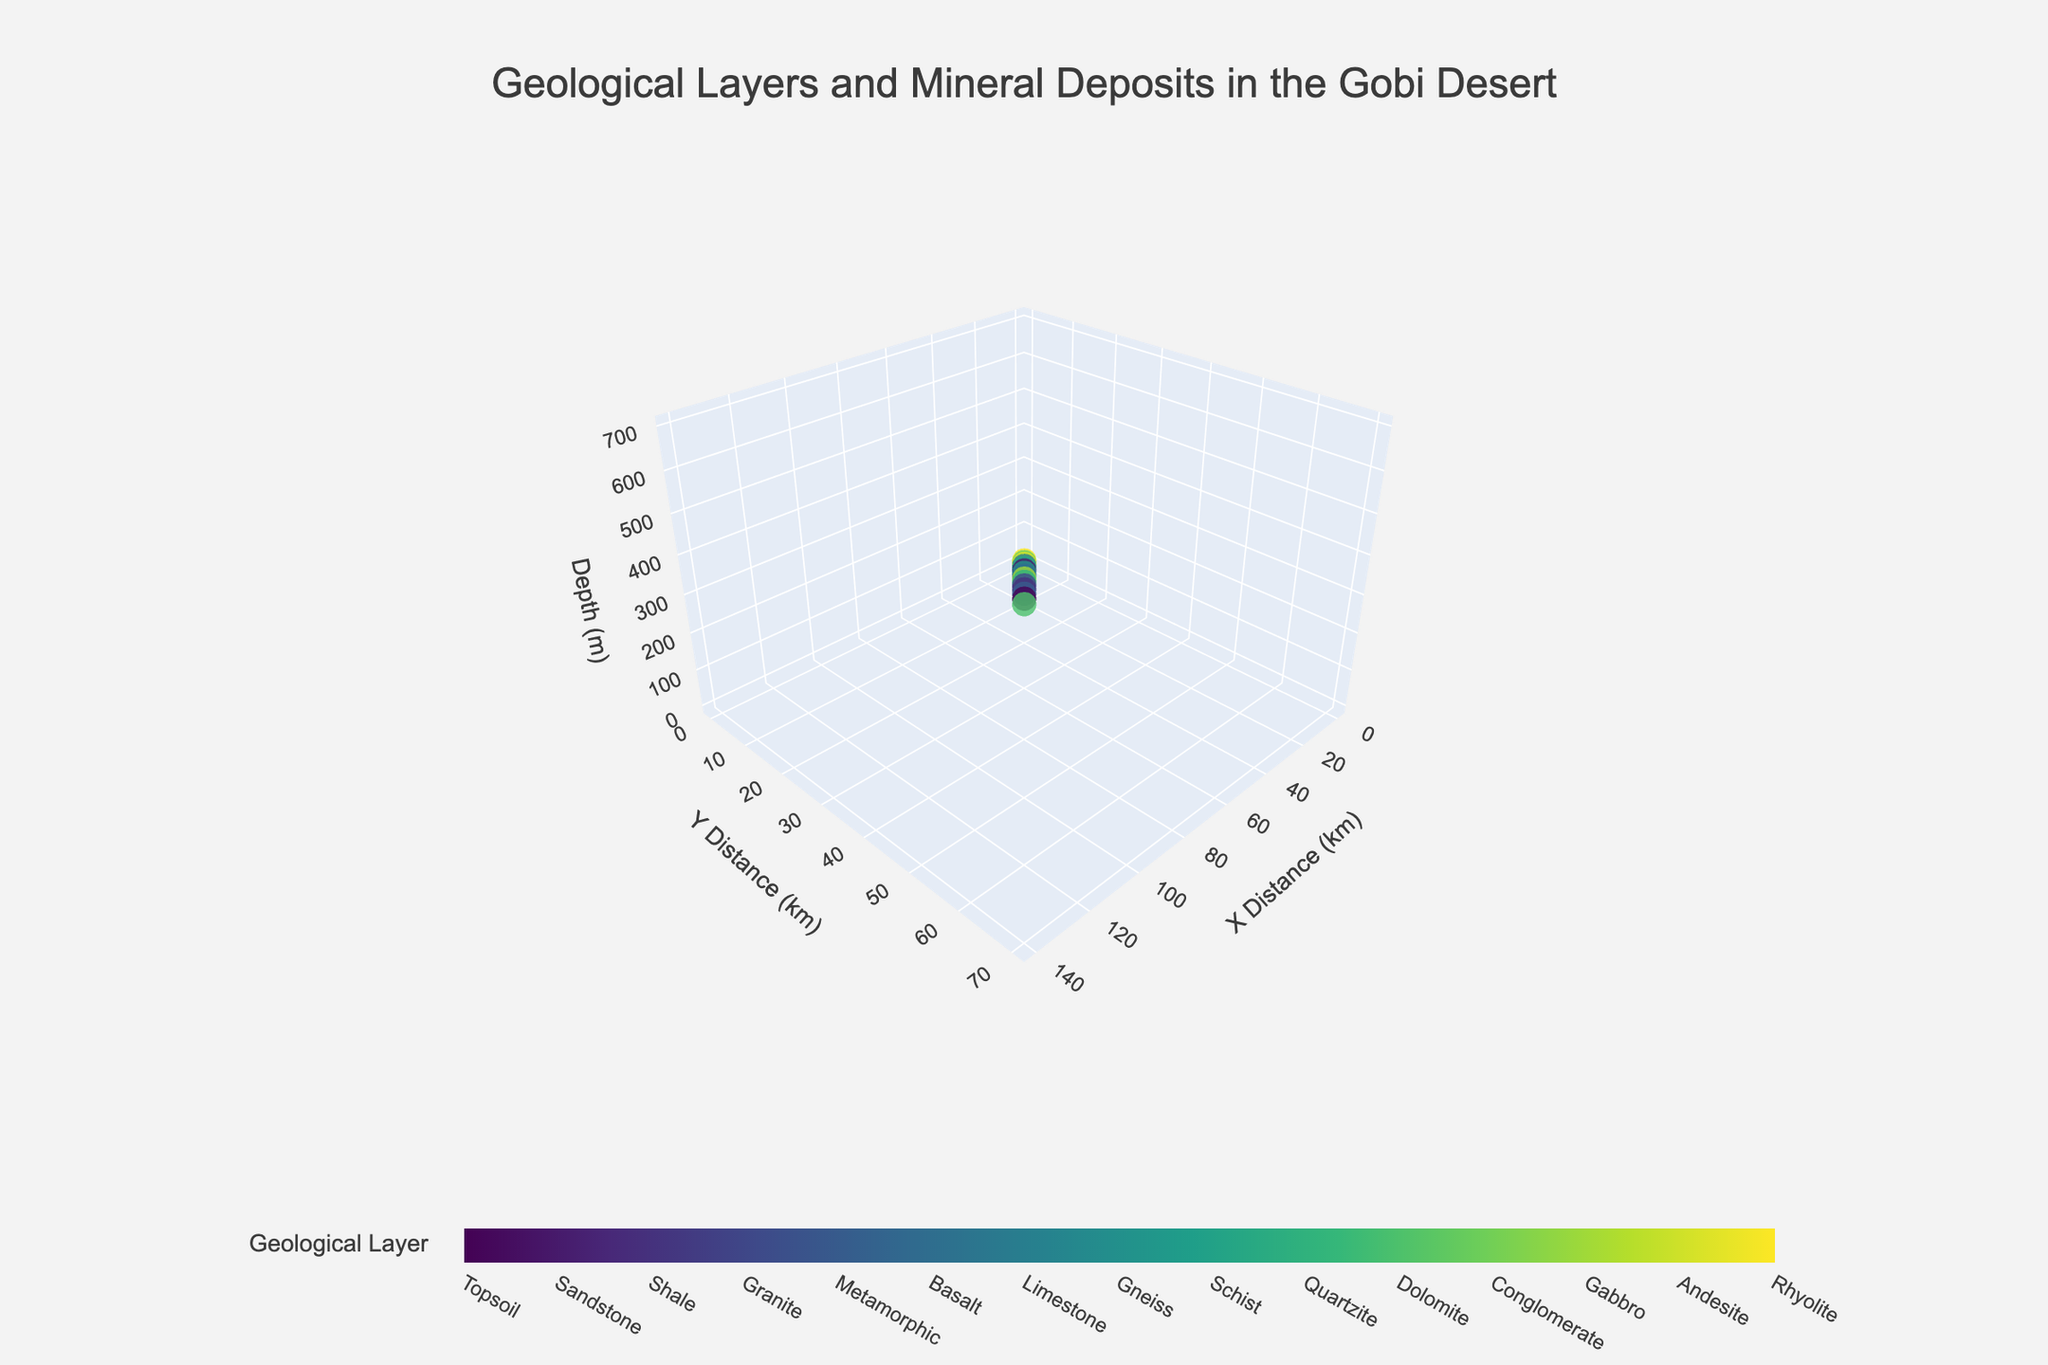What's the title of the figure? The title of the figure is prominently displayed at the top center and reads "Geological Layers and Mineral Deposits in the Gobi Desert".
Answer: Geological Layers and Mineral Deposits in the Gobi Desert What is the depth range (in meters) represented in the plot? The z-axis title indicates depth in meters, and the axis starts at 0 meters and extends to 700 meters.
Answer: 0 to 700 meters How many geological layers are represented in the plot? The color bar legend shows unique tick values with different geological layer names. Counting these unique layers gives us the total number.
Answer: 15 Which mineral is deposited at the deepest point in the plot? By observing the z-axis for the deepest point (700 meters), the plot shows Rhyolite, which has None listed. Another point has Andesite (650 meters), with Silver.
Answer: Silver Are there any geological layers that do not contain minerals? The text associated with the marker can be examined. If a marker has "None" in its hover text, it means it does not contain minerals. Topsoil, Basalt, Schist, Rhyolite, and Conglomerate have "None" listed as minerals.
Answer: Yes Which layer has the highest concentration of a valuable mineral (like gold or platinum)? By observing the plot and looking for the layers where minerals like gold and platinum are present, we find that Gold is in the Metamorphic layer, and Platinum in the Gabbro layer. Checking the z-values, Gold is deeper in its highest concentration at 200 meters.
Answer: Metamorphic What is the geological layer present at the coordinates (10 km, 5 km)? The marker at the given coordinates (10, 5) can be seen on the plot, and the hover text reveals it is "Sandstone" with Copper deposits.
Answer: Sandstone What is the difference in depth between the Shale and the Limestone layers? The z-values for Shale and Limestone layers can be identified from the plot. Shale is at 100 meters, and Limestone at 300 meters. The difference between these depths is 300 - 100.
Answer: 200 meters Which layers have rare earth elements? By examining the hover text for each marker, we find that Rare Earth Elements are present in the Gneiss layer.
Answer: Gneiss Based on the range of z-values, which geological layer covers the most extensive depth range? Observing the distance on the z-axis for each geological layer, we check the starting and ending depth of each layer. Without overlap assessment directly, layers can be compared. The z-axis range must be 0 to 50 for Sandstone, being earlier depths wider relative.
Answer: Sandstone 